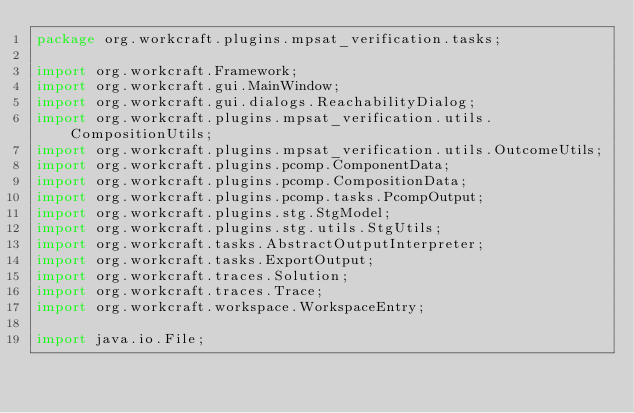<code> <loc_0><loc_0><loc_500><loc_500><_Java_>package org.workcraft.plugins.mpsat_verification.tasks;

import org.workcraft.Framework;
import org.workcraft.gui.MainWindow;
import org.workcraft.gui.dialogs.ReachabilityDialog;
import org.workcraft.plugins.mpsat_verification.utils.CompositionUtils;
import org.workcraft.plugins.mpsat_verification.utils.OutcomeUtils;
import org.workcraft.plugins.pcomp.ComponentData;
import org.workcraft.plugins.pcomp.CompositionData;
import org.workcraft.plugins.pcomp.tasks.PcompOutput;
import org.workcraft.plugins.stg.StgModel;
import org.workcraft.plugins.stg.utils.StgUtils;
import org.workcraft.tasks.AbstractOutputInterpreter;
import org.workcraft.tasks.ExportOutput;
import org.workcraft.traces.Solution;
import org.workcraft.traces.Trace;
import org.workcraft.workspace.WorkspaceEntry;

import java.io.File;</code> 